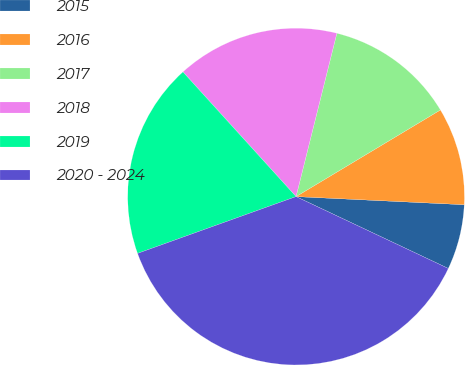<chart> <loc_0><loc_0><loc_500><loc_500><pie_chart><fcel>2015<fcel>2016<fcel>2017<fcel>2018<fcel>2019<fcel>2020 - 2024<nl><fcel>6.25%<fcel>9.37%<fcel>12.5%<fcel>15.62%<fcel>18.75%<fcel>37.5%<nl></chart> 